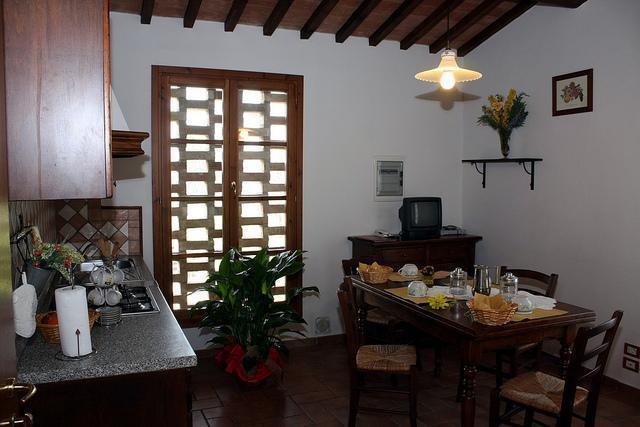How many plants are in the room?
Give a very brief answer. 2. How many chairs are in the picture?
Give a very brief answer. 3. How many people are wearing blue shirt?
Give a very brief answer. 0. 